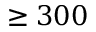<formula> <loc_0><loc_0><loc_500><loc_500>\geq 3 0 0</formula> 